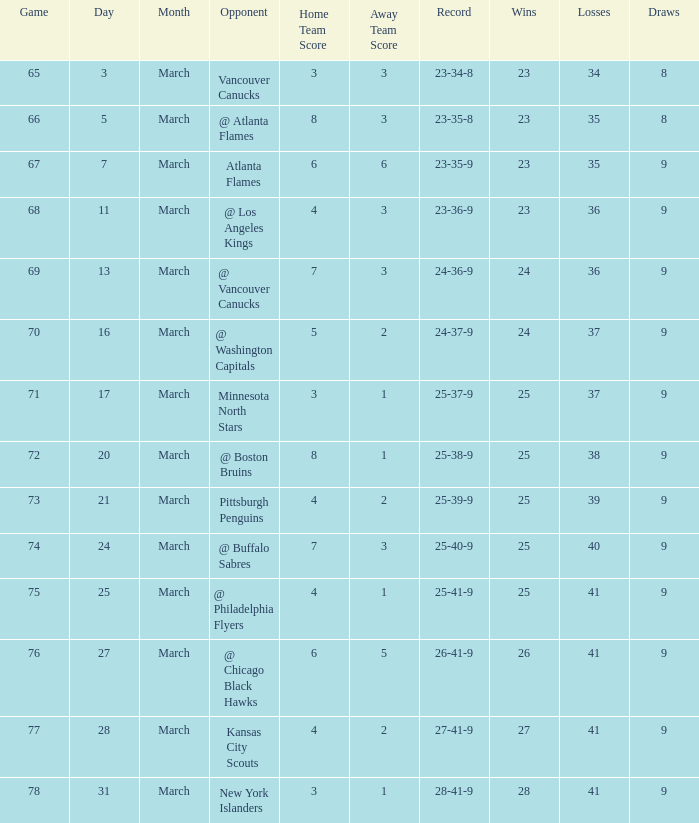What is the game associated with a score of 4 - 2, and a record of 25-39-9? 73.0. 